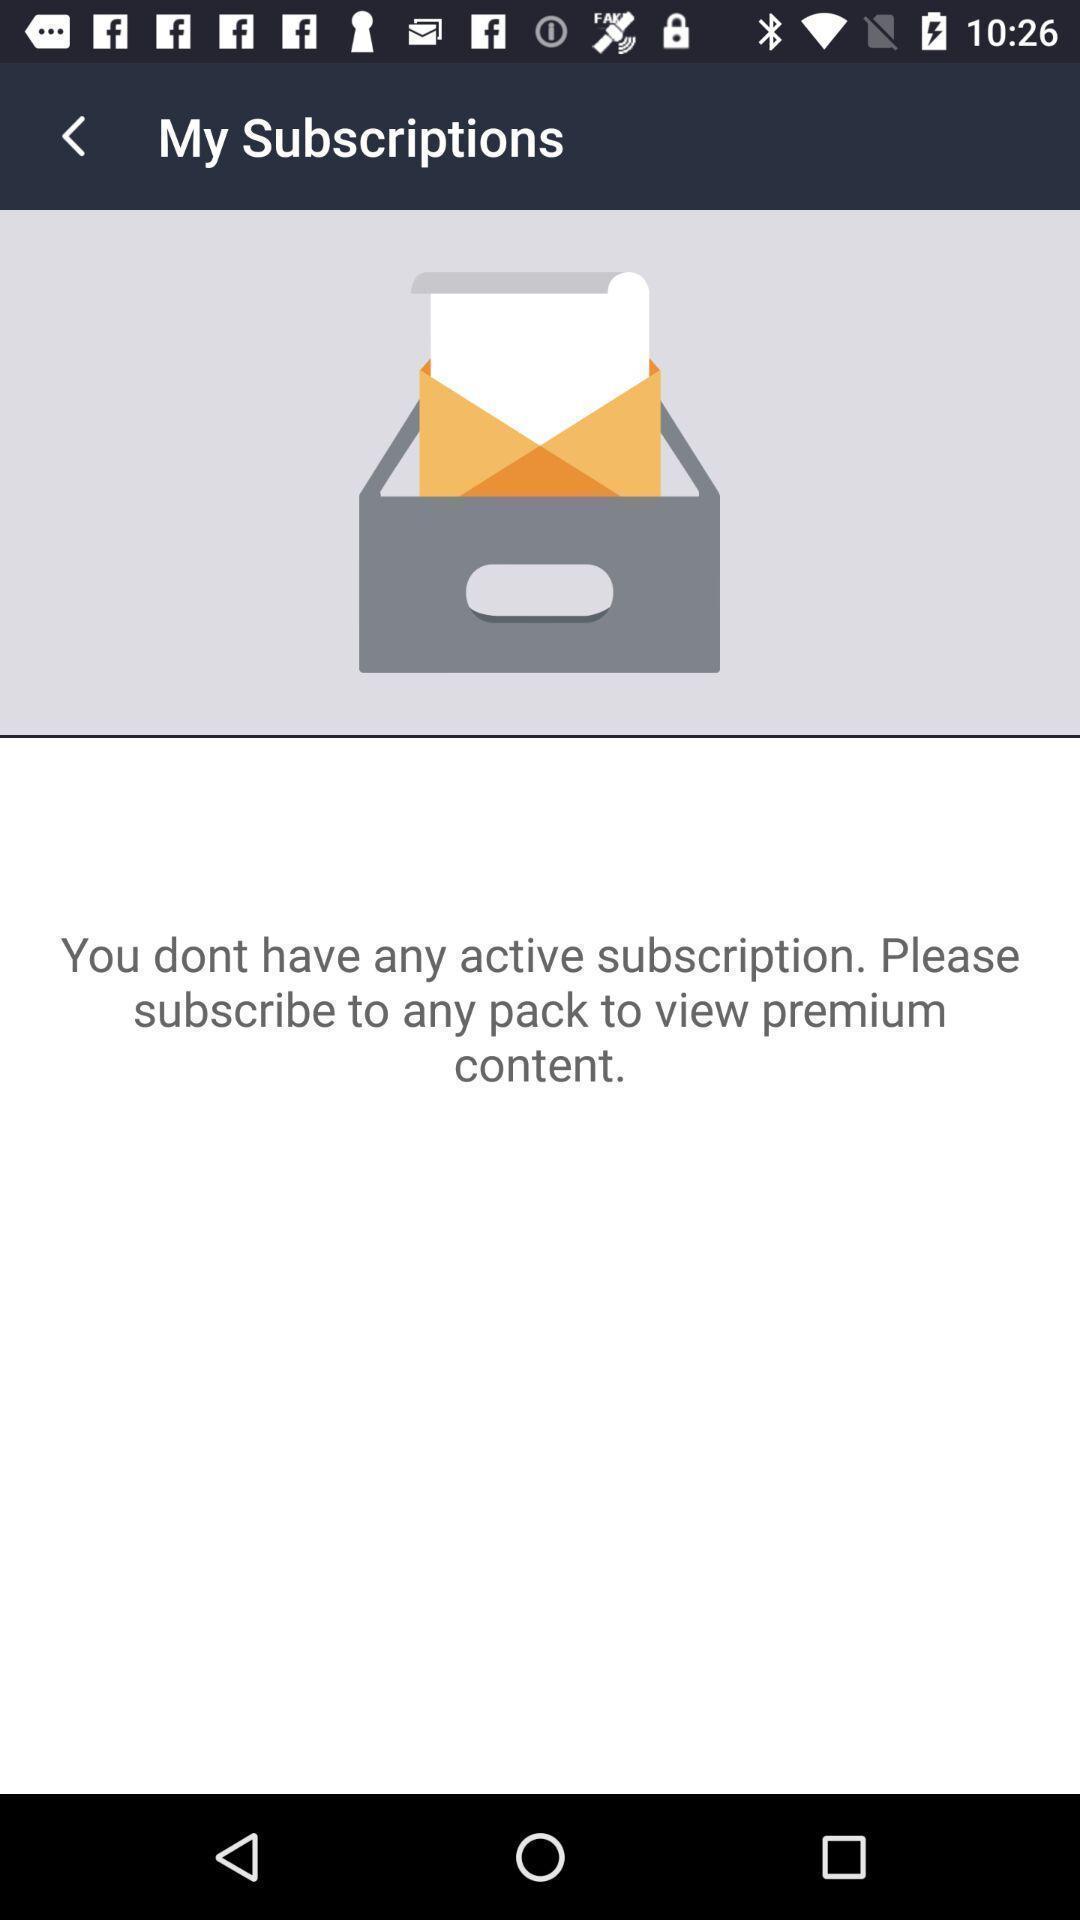Describe the visual elements of this screenshot. Subscription page for live tv in mobile. 